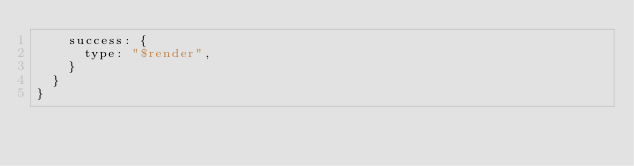Convert code to text. <code><loc_0><loc_0><loc_500><loc_500><_JavaScript_>    success: {
      type: "$render",
    }
  }
}
</code> 